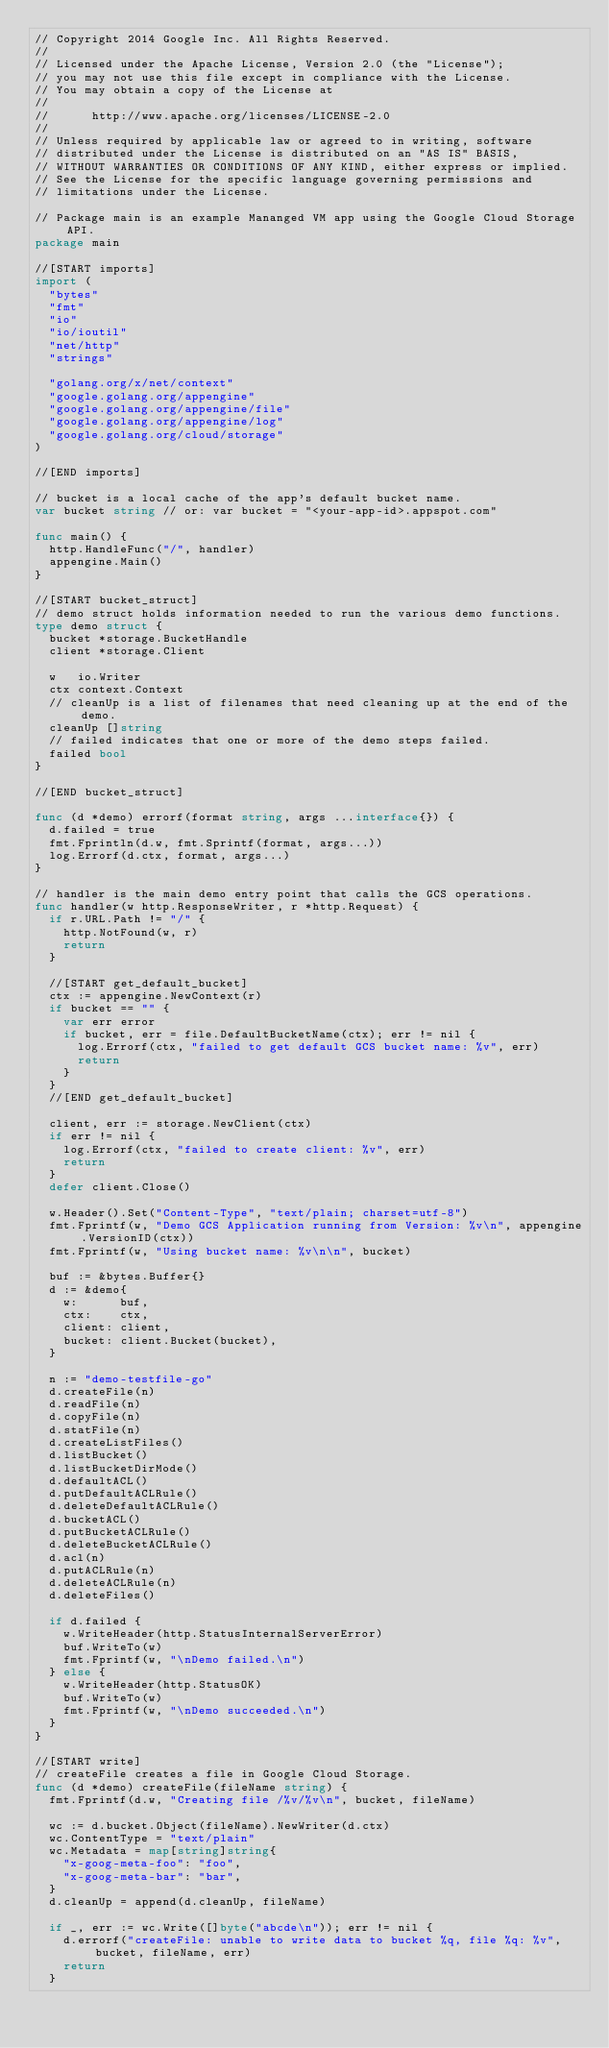<code> <loc_0><loc_0><loc_500><loc_500><_Go_>// Copyright 2014 Google Inc. All Rights Reserved.
//
// Licensed under the Apache License, Version 2.0 (the "License");
// you may not use this file except in compliance with the License.
// You may obtain a copy of the License at
//
//      http://www.apache.org/licenses/LICENSE-2.0
//
// Unless required by applicable law or agreed to in writing, software
// distributed under the License is distributed on an "AS IS" BASIS,
// WITHOUT WARRANTIES OR CONDITIONS OF ANY KIND, either express or implied.
// See the License for the specific language governing permissions and
// limitations under the License.

// Package main is an example Mananged VM app using the Google Cloud Storage API.
package main

//[START imports]
import (
	"bytes"
	"fmt"
	"io"
	"io/ioutil"
	"net/http"
	"strings"

	"golang.org/x/net/context"
	"google.golang.org/appengine"
	"google.golang.org/appengine/file"
	"google.golang.org/appengine/log"
	"google.golang.org/cloud/storage"
)

//[END imports]

// bucket is a local cache of the app's default bucket name.
var bucket string // or: var bucket = "<your-app-id>.appspot.com"

func main() {
	http.HandleFunc("/", handler)
	appengine.Main()
}

//[START bucket_struct]
// demo struct holds information needed to run the various demo functions.
type demo struct {
	bucket *storage.BucketHandle
	client *storage.Client

	w   io.Writer
	ctx context.Context
	// cleanUp is a list of filenames that need cleaning up at the end of the demo.
	cleanUp []string
	// failed indicates that one or more of the demo steps failed.
	failed bool
}

//[END bucket_struct]

func (d *demo) errorf(format string, args ...interface{}) {
	d.failed = true
	fmt.Fprintln(d.w, fmt.Sprintf(format, args...))
	log.Errorf(d.ctx, format, args...)
}

// handler is the main demo entry point that calls the GCS operations.
func handler(w http.ResponseWriter, r *http.Request) {
	if r.URL.Path != "/" {
		http.NotFound(w, r)
		return
	}

	//[START get_default_bucket]
	ctx := appengine.NewContext(r)
	if bucket == "" {
		var err error
		if bucket, err = file.DefaultBucketName(ctx); err != nil {
			log.Errorf(ctx, "failed to get default GCS bucket name: %v", err)
			return
		}
	}
	//[END get_default_bucket]

	client, err := storage.NewClient(ctx)
	if err != nil {
		log.Errorf(ctx, "failed to create client: %v", err)
		return
	}
	defer client.Close()

	w.Header().Set("Content-Type", "text/plain; charset=utf-8")
	fmt.Fprintf(w, "Demo GCS Application running from Version: %v\n", appengine.VersionID(ctx))
	fmt.Fprintf(w, "Using bucket name: %v\n\n", bucket)

	buf := &bytes.Buffer{}
	d := &demo{
		w:      buf,
		ctx:    ctx,
		client: client,
		bucket: client.Bucket(bucket),
	}

	n := "demo-testfile-go"
	d.createFile(n)
	d.readFile(n)
	d.copyFile(n)
	d.statFile(n)
	d.createListFiles()
	d.listBucket()
	d.listBucketDirMode()
	d.defaultACL()
	d.putDefaultACLRule()
	d.deleteDefaultACLRule()
	d.bucketACL()
	d.putBucketACLRule()
	d.deleteBucketACLRule()
	d.acl(n)
	d.putACLRule(n)
	d.deleteACLRule(n)
	d.deleteFiles()

	if d.failed {
		w.WriteHeader(http.StatusInternalServerError)
		buf.WriteTo(w)
		fmt.Fprintf(w, "\nDemo failed.\n")
	} else {
		w.WriteHeader(http.StatusOK)
		buf.WriteTo(w)
		fmt.Fprintf(w, "\nDemo succeeded.\n")
	}
}

//[START write]
// createFile creates a file in Google Cloud Storage.
func (d *demo) createFile(fileName string) {
	fmt.Fprintf(d.w, "Creating file /%v/%v\n", bucket, fileName)

	wc := d.bucket.Object(fileName).NewWriter(d.ctx)
	wc.ContentType = "text/plain"
	wc.Metadata = map[string]string{
		"x-goog-meta-foo": "foo",
		"x-goog-meta-bar": "bar",
	}
	d.cleanUp = append(d.cleanUp, fileName)

	if _, err := wc.Write([]byte("abcde\n")); err != nil {
		d.errorf("createFile: unable to write data to bucket %q, file %q: %v", bucket, fileName, err)
		return
	}</code> 